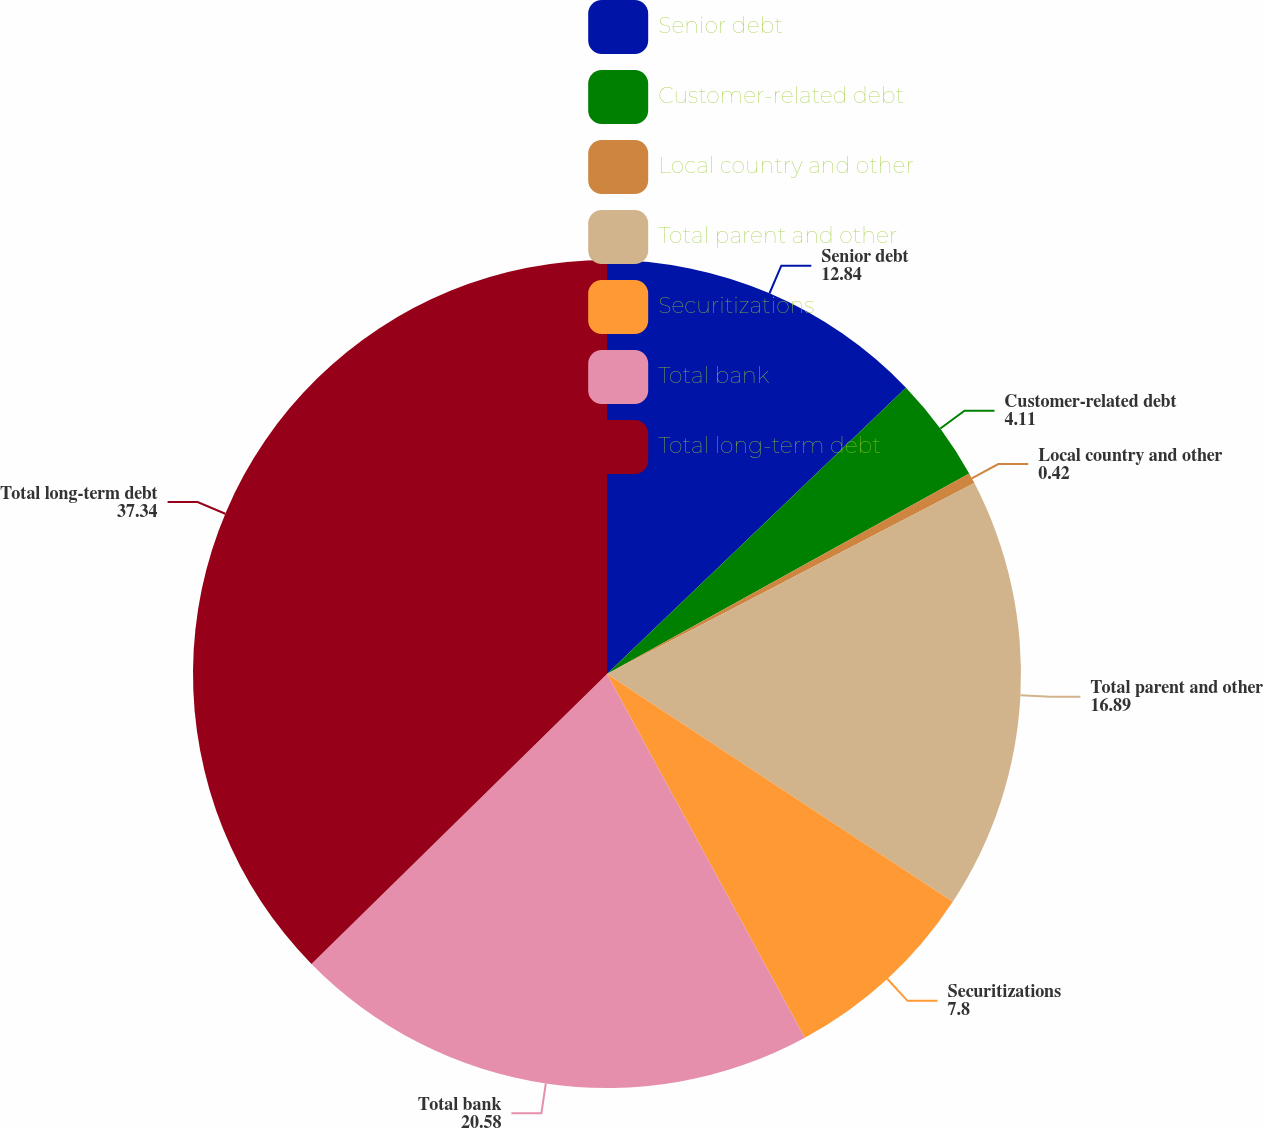Convert chart. <chart><loc_0><loc_0><loc_500><loc_500><pie_chart><fcel>Senior debt<fcel>Customer-related debt<fcel>Local country and other<fcel>Total parent and other<fcel>Securitizations<fcel>Total bank<fcel>Total long-term debt<nl><fcel>12.84%<fcel>4.11%<fcel>0.42%<fcel>16.89%<fcel>7.8%<fcel>20.58%<fcel>37.34%<nl></chart> 